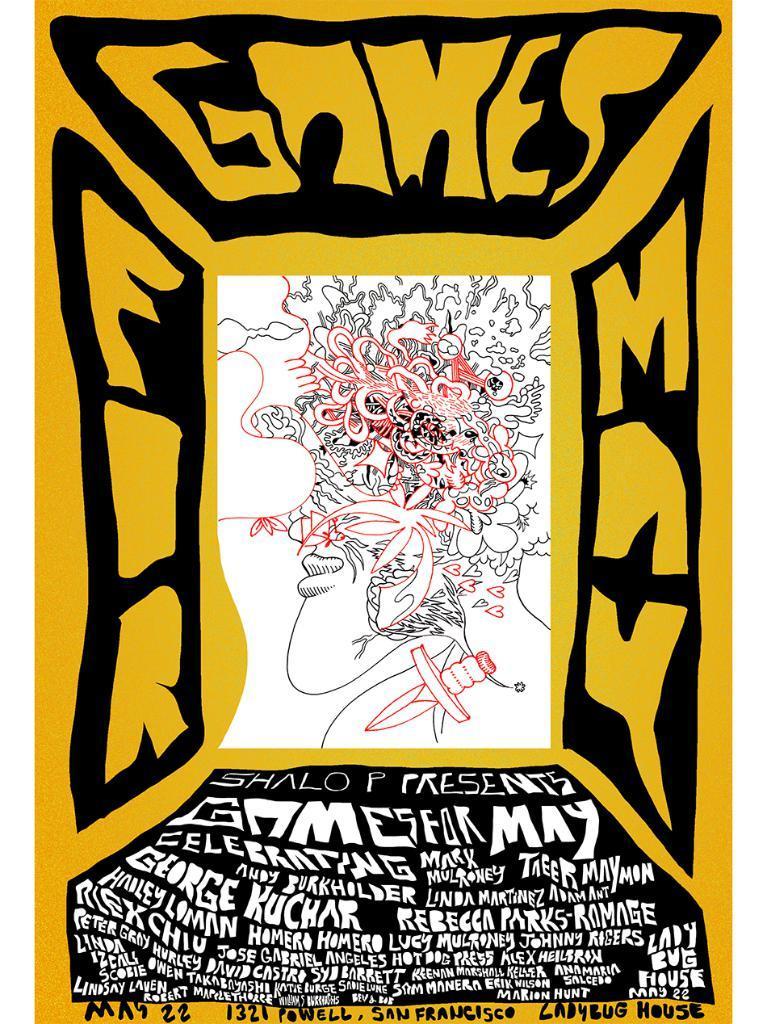How would you summarize this image in a sentence or two? In this image we can see a poster with sketch and text. 